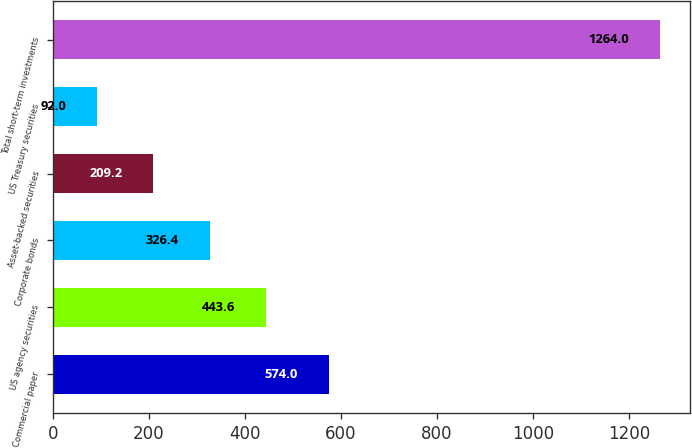Convert chart. <chart><loc_0><loc_0><loc_500><loc_500><bar_chart><fcel>Commercial paper<fcel>US agency securities<fcel>Corporate bonds<fcel>Asset-backed securities<fcel>US Treasury securities<fcel>Total short-term investments<nl><fcel>574<fcel>443.6<fcel>326.4<fcel>209.2<fcel>92<fcel>1264<nl></chart> 